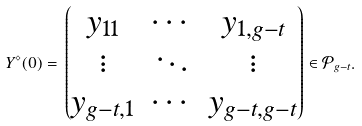Convert formula to latex. <formula><loc_0><loc_0><loc_500><loc_500>Y ^ { \diamond } ( 0 ) = \, \begin{pmatrix} y _ { 1 1 } & \cdots & y _ { 1 , g - t } \\ \vdots & \ddots & \vdots \\ y _ { g - t , 1 } & \cdots & y _ { g - t , g - t } \end{pmatrix} \in { \mathcal { P } } _ { g - t } .</formula> 